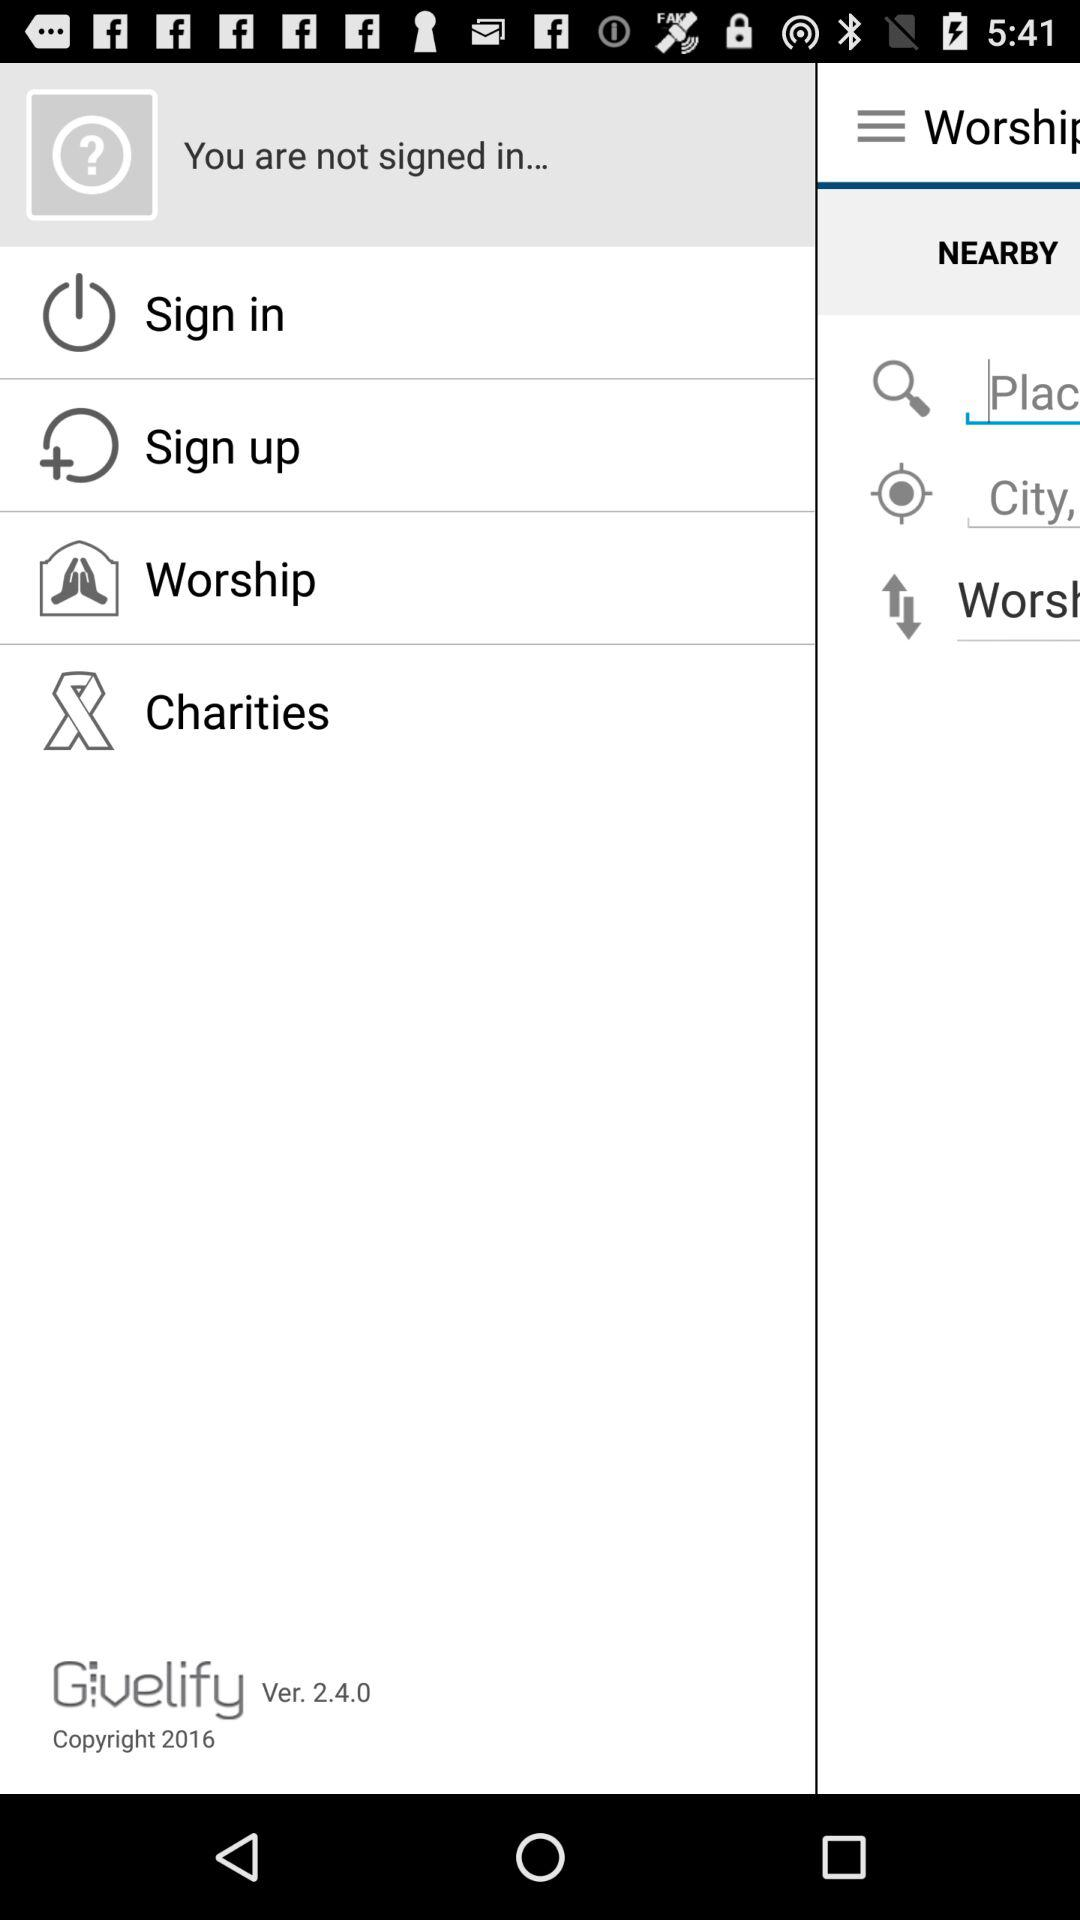What is the copyright year? The copyright year is 2016. 